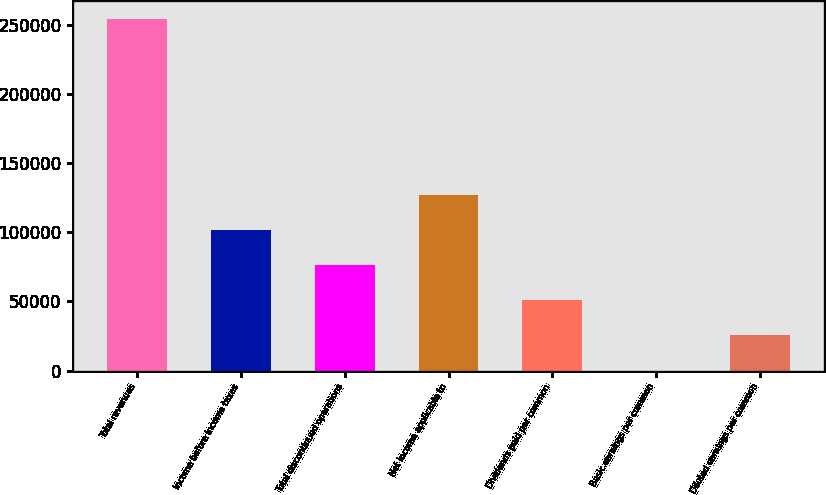<chart> <loc_0><loc_0><loc_500><loc_500><bar_chart><fcel>Total revenues<fcel>Income before income taxes<fcel>Total discontinued operations<fcel>Net income applicable to<fcel>Dividends paid per common<fcel>Basic earnings per common<fcel>Diluted earnings per common<nl><fcel>254281<fcel>101713<fcel>76284.4<fcel>127141<fcel>50856.4<fcel>0.21<fcel>25428.3<nl></chart> 